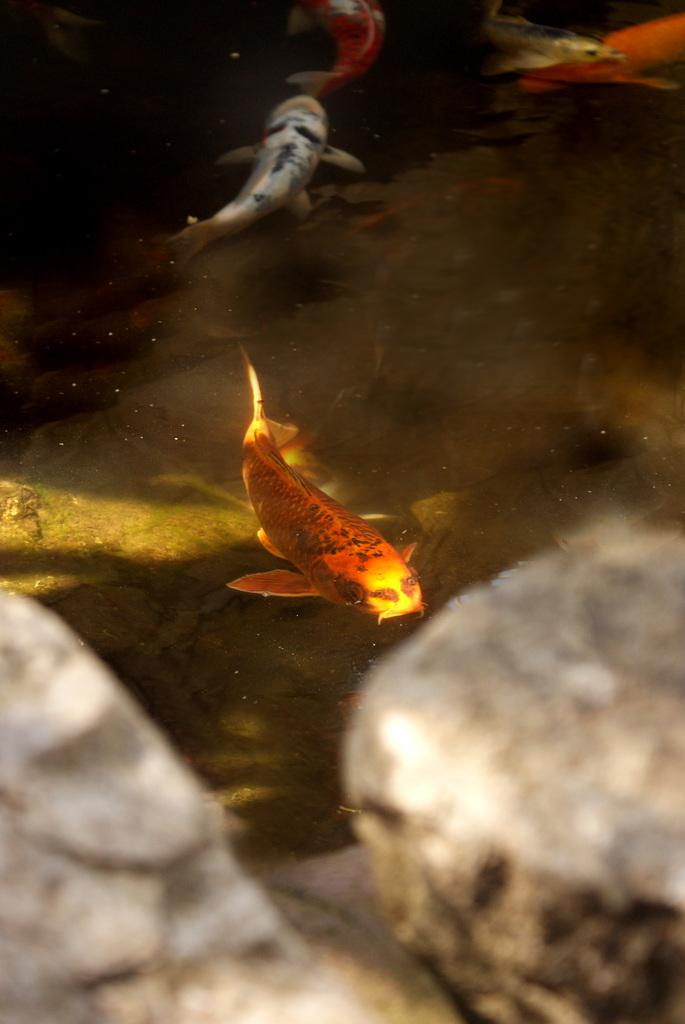What type of animals can be seen in the image? There are fishes in the image. What else is present in the water in the image? There are stones in the water in the image. What type of road can be seen in the image? There is no road present in the image; it features fishes and stones in the water. Can you tell me what the bats are doing in the image? There are no bats present in the image. 